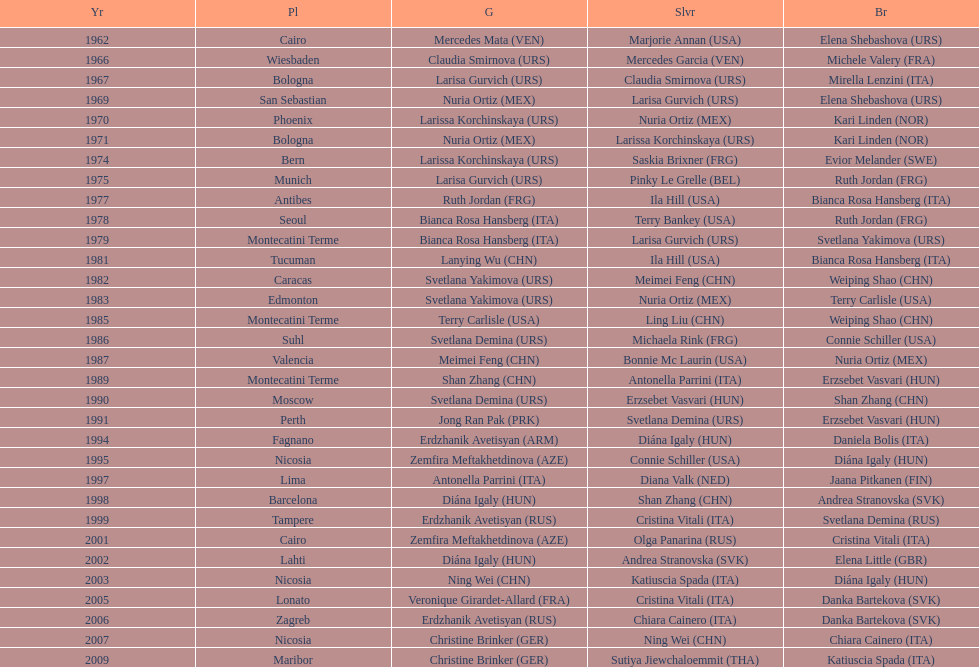Help me parse the entirety of this table. {'header': ['Yr', 'Pl', 'G', 'Slvr', 'Br'], 'rows': [['1962', 'Cairo', 'Mercedes Mata\xa0(VEN)', 'Marjorie Annan\xa0(USA)', 'Elena Shebashova\xa0(URS)'], ['1966', 'Wiesbaden', 'Claudia Smirnova\xa0(URS)', 'Mercedes Garcia\xa0(VEN)', 'Michele Valery\xa0(FRA)'], ['1967', 'Bologna', 'Larisa Gurvich\xa0(URS)', 'Claudia Smirnova\xa0(URS)', 'Mirella Lenzini\xa0(ITA)'], ['1969', 'San Sebastian', 'Nuria Ortiz\xa0(MEX)', 'Larisa Gurvich\xa0(URS)', 'Elena Shebashova\xa0(URS)'], ['1970', 'Phoenix', 'Larissa Korchinskaya\xa0(URS)', 'Nuria Ortiz\xa0(MEX)', 'Kari Linden\xa0(NOR)'], ['1971', 'Bologna', 'Nuria Ortiz\xa0(MEX)', 'Larissa Korchinskaya\xa0(URS)', 'Kari Linden\xa0(NOR)'], ['1974', 'Bern', 'Larissa Korchinskaya\xa0(URS)', 'Saskia Brixner\xa0(FRG)', 'Evior Melander\xa0(SWE)'], ['1975', 'Munich', 'Larisa Gurvich\xa0(URS)', 'Pinky Le Grelle\xa0(BEL)', 'Ruth Jordan\xa0(FRG)'], ['1977', 'Antibes', 'Ruth Jordan\xa0(FRG)', 'Ila Hill\xa0(USA)', 'Bianca Rosa Hansberg\xa0(ITA)'], ['1978', 'Seoul', 'Bianca Rosa Hansberg\xa0(ITA)', 'Terry Bankey\xa0(USA)', 'Ruth Jordan\xa0(FRG)'], ['1979', 'Montecatini Terme', 'Bianca Rosa Hansberg\xa0(ITA)', 'Larisa Gurvich\xa0(URS)', 'Svetlana Yakimova\xa0(URS)'], ['1981', 'Tucuman', 'Lanying Wu\xa0(CHN)', 'Ila Hill\xa0(USA)', 'Bianca Rosa Hansberg\xa0(ITA)'], ['1982', 'Caracas', 'Svetlana Yakimova\xa0(URS)', 'Meimei Feng\xa0(CHN)', 'Weiping Shao\xa0(CHN)'], ['1983', 'Edmonton', 'Svetlana Yakimova\xa0(URS)', 'Nuria Ortiz\xa0(MEX)', 'Terry Carlisle\xa0(USA)'], ['1985', 'Montecatini Terme', 'Terry Carlisle\xa0(USA)', 'Ling Liu\xa0(CHN)', 'Weiping Shao\xa0(CHN)'], ['1986', 'Suhl', 'Svetlana Demina\xa0(URS)', 'Michaela Rink\xa0(FRG)', 'Connie Schiller\xa0(USA)'], ['1987', 'Valencia', 'Meimei Feng\xa0(CHN)', 'Bonnie Mc Laurin\xa0(USA)', 'Nuria Ortiz\xa0(MEX)'], ['1989', 'Montecatini Terme', 'Shan Zhang\xa0(CHN)', 'Antonella Parrini\xa0(ITA)', 'Erzsebet Vasvari\xa0(HUN)'], ['1990', 'Moscow', 'Svetlana Demina\xa0(URS)', 'Erzsebet Vasvari\xa0(HUN)', 'Shan Zhang\xa0(CHN)'], ['1991', 'Perth', 'Jong Ran Pak\xa0(PRK)', 'Svetlana Demina\xa0(URS)', 'Erzsebet Vasvari\xa0(HUN)'], ['1994', 'Fagnano', 'Erdzhanik Avetisyan\xa0(ARM)', 'Diána Igaly\xa0(HUN)', 'Daniela Bolis\xa0(ITA)'], ['1995', 'Nicosia', 'Zemfira Meftakhetdinova\xa0(AZE)', 'Connie Schiller\xa0(USA)', 'Diána Igaly\xa0(HUN)'], ['1997', 'Lima', 'Antonella Parrini\xa0(ITA)', 'Diana Valk\xa0(NED)', 'Jaana Pitkanen\xa0(FIN)'], ['1998', 'Barcelona', 'Diána Igaly\xa0(HUN)', 'Shan Zhang\xa0(CHN)', 'Andrea Stranovska\xa0(SVK)'], ['1999', 'Tampere', 'Erdzhanik Avetisyan\xa0(RUS)', 'Cristina Vitali\xa0(ITA)', 'Svetlana Demina\xa0(RUS)'], ['2001', 'Cairo', 'Zemfira Meftakhetdinova\xa0(AZE)', 'Olga Panarina\xa0(RUS)', 'Cristina Vitali\xa0(ITA)'], ['2002', 'Lahti', 'Diána Igaly\xa0(HUN)', 'Andrea Stranovska\xa0(SVK)', 'Elena Little\xa0(GBR)'], ['2003', 'Nicosia', 'Ning Wei\xa0(CHN)', 'Katiuscia Spada\xa0(ITA)', 'Diána Igaly\xa0(HUN)'], ['2005', 'Lonato', 'Veronique Girardet-Allard\xa0(FRA)', 'Cristina Vitali\xa0(ITA)', 'Danka Bartekova\xa0(SVK)'], ['2006', 'Zagreb', 'Erdzhanik Avetisyan\xa0(RUS)', 'Chiara Cainero\xa0(ITA)', 'Danka Bartekova\xa0(SVK)'], ['2007', 'Nicosia', 'Christine Brinker\xa0(GER)', 'Ning Wei\xa0(CHN)', 'Chiara Cainero\xa0(ITA)'], ['2009', 'Maribor', 'Christine Brinker\xa0(GER)', 'Sutiya Jiewchaloemmit\xa0(THA)', 'Katiuscia Spada\xa0(ITA)']]} How many gold did u.s.a win 1. 